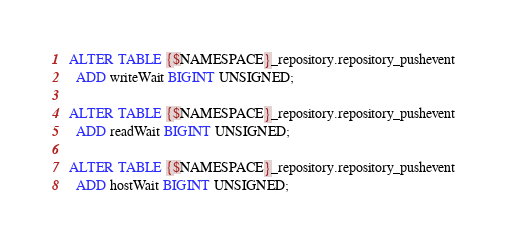<code> <loc_0><loc_0><loc_500><loc_500><_SQL_>ALTER TABLE {$NAMESPACE}_repository.repository_pushevent
  ADD writeWait BIGINT UNSIGNED;

ALTER TABLE {$NAMESPACE}_repository.repository_pushevent
  ADD readWait BIGINT UNSIGNED;

ALTER TABLE {$NAMESPACE}_repository.repository_pushevent
  ADD hostWait BIGINT UNSIGNED;
</code> 